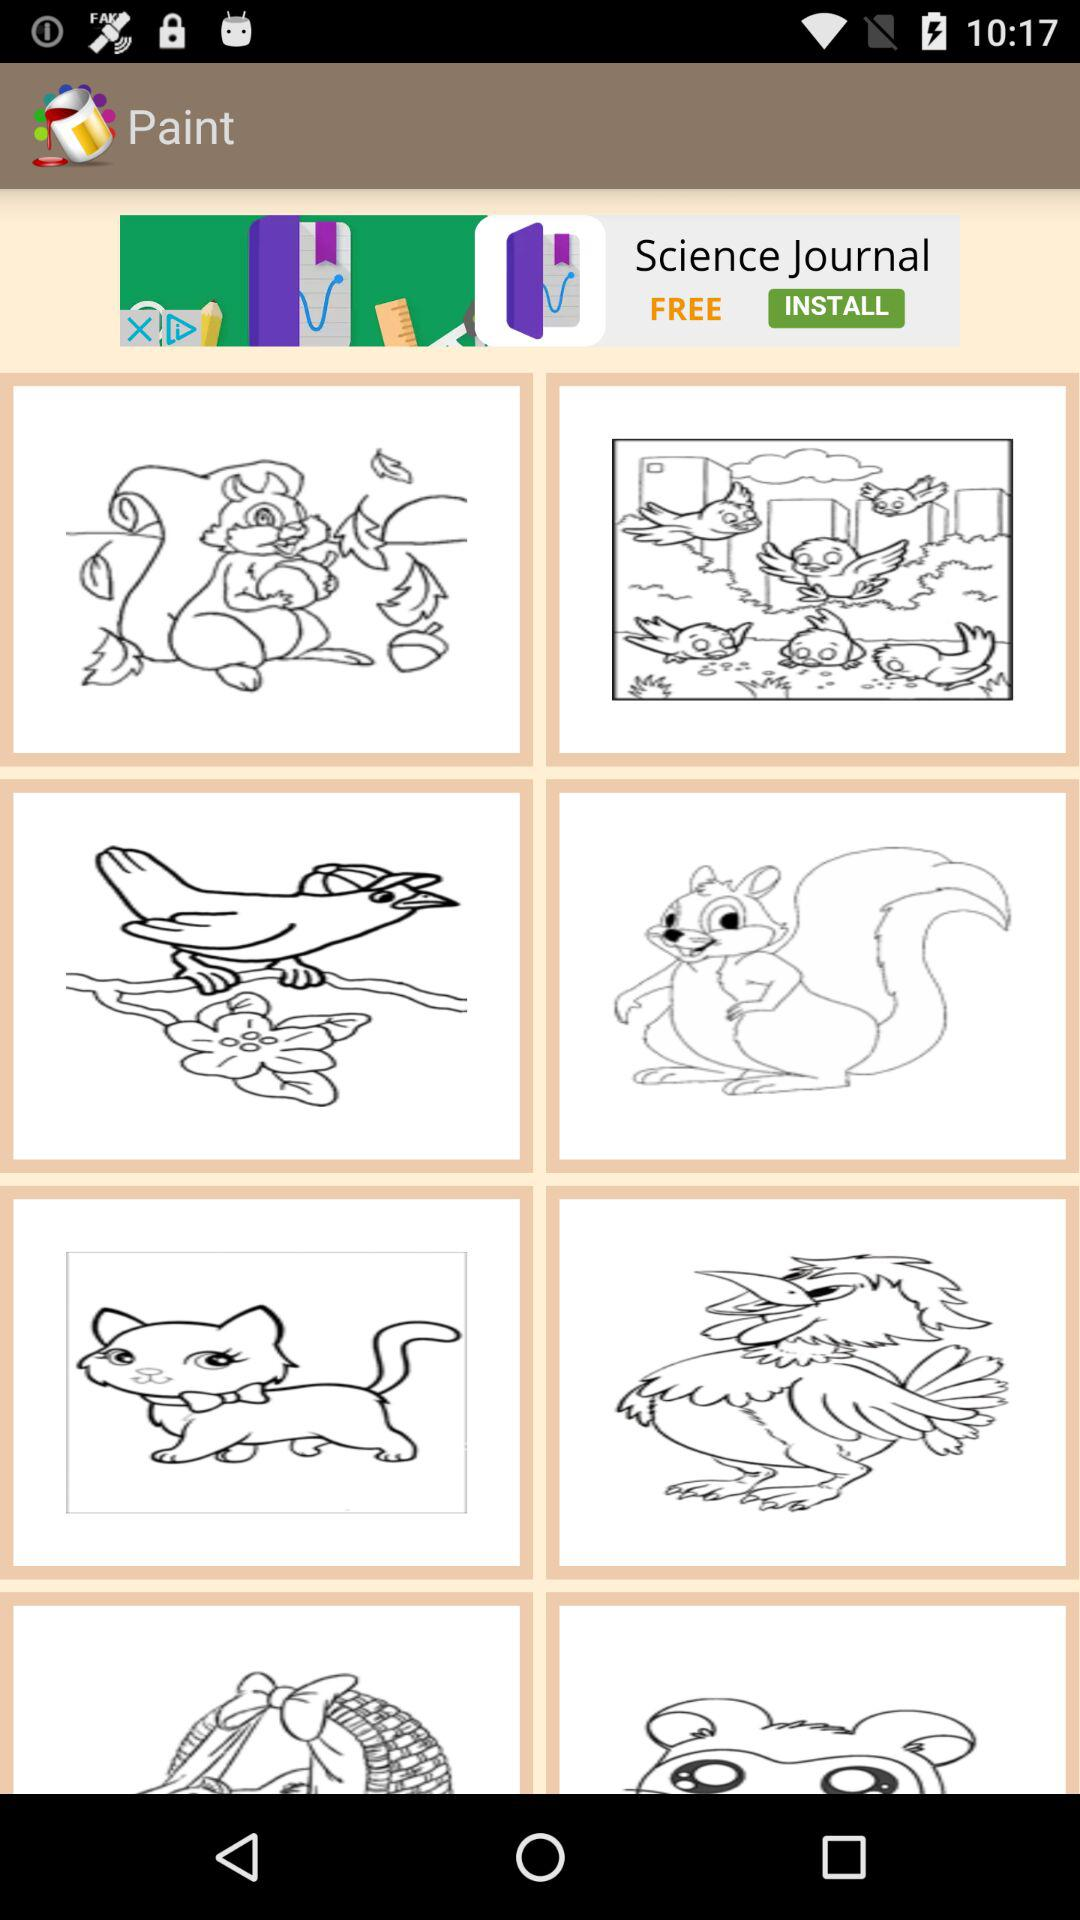What is the name of the application? The name of the application is "Paint". 